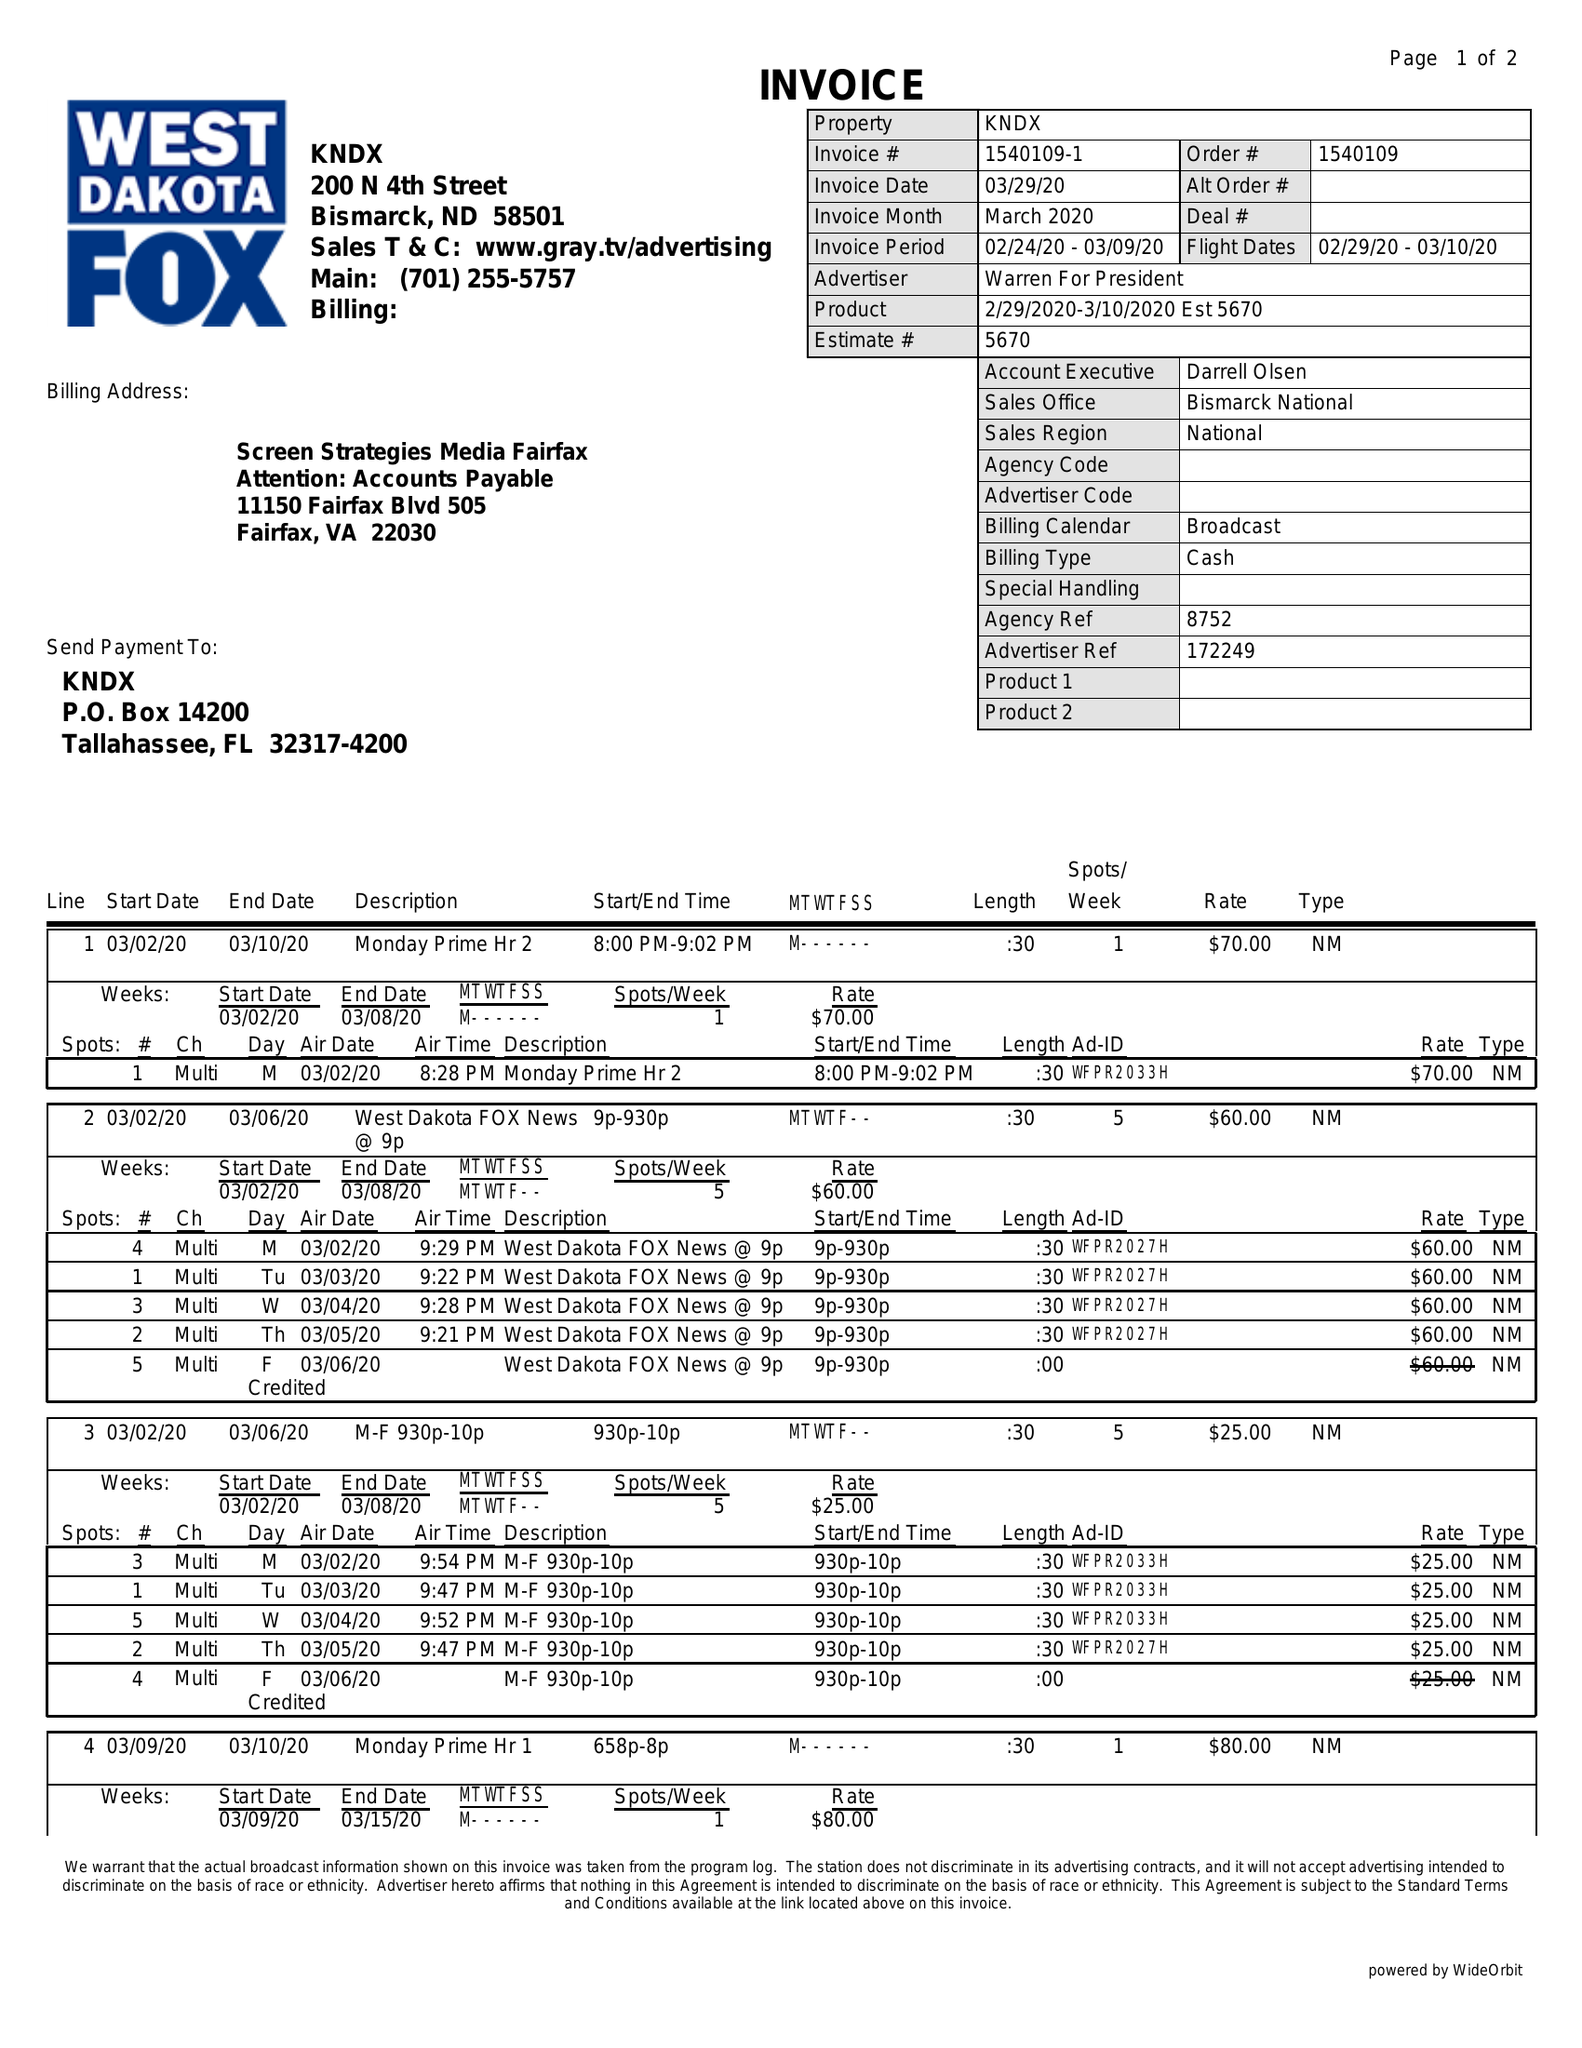What is the value for the flight_from?
Answer the question using a single word or phrase. 02/29/20 